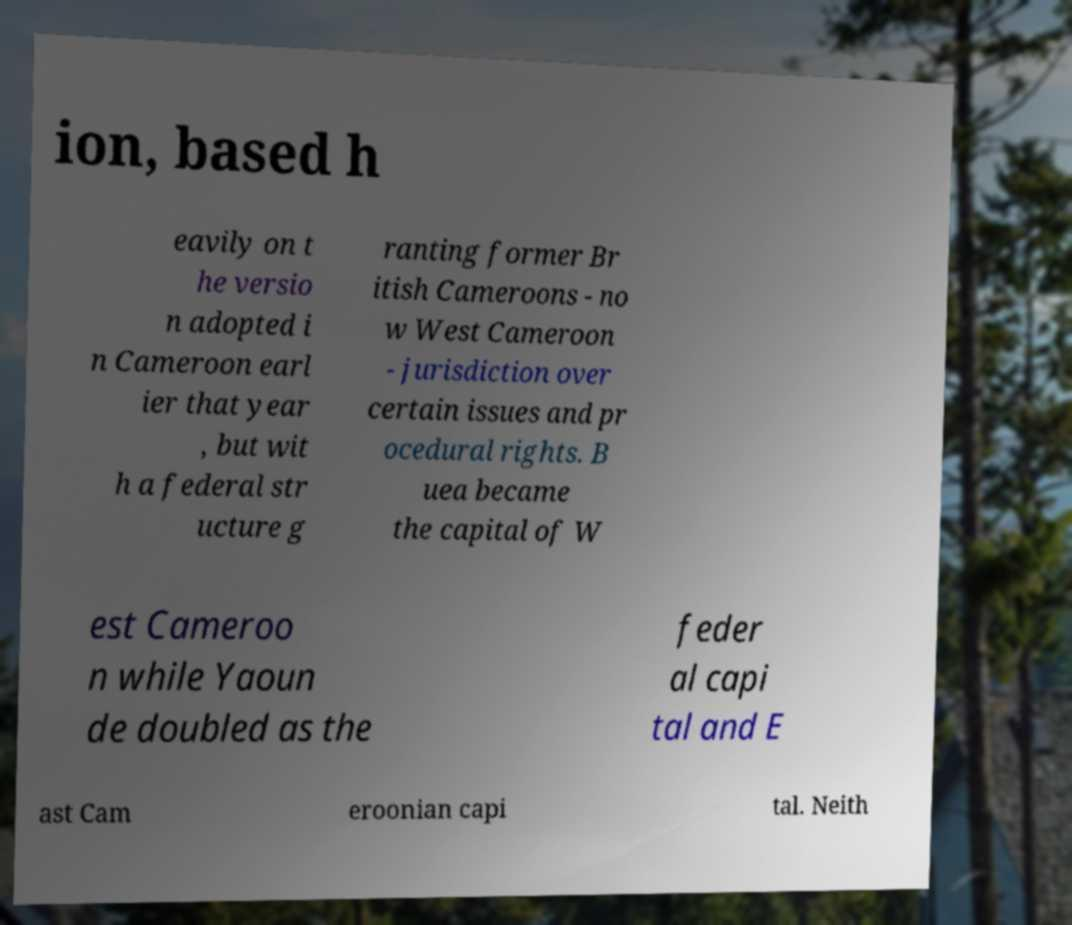What messages or text are displayed in this image? I need them in a readable, typed format. ion, based h eavily on t he versio n adopted i n Cameroon earl ier that year , but wit h a federal str ucture g ranting former Br itish Cameroons - no w West Cameroon - jurisdiction over certain issues and pr ocedural rights. B uea became the capital of W est Cameroo n while Yaoun de doubled as the feder al capi tal and E ast Cam eroonian capi tal. Neith 